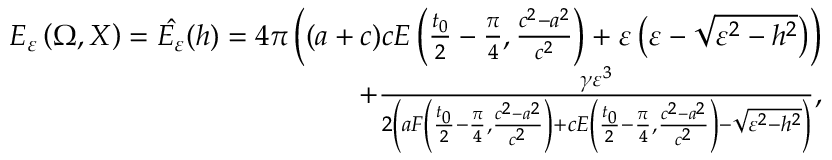Convert formula to latex. <formula><loc_0><loc_0><loc_500><loc_500>\begin{array} { r } { E _ { \varepsilon } \left ( \Omega , X \right ) = \hat { E _ { \varepsilon } } ( h ) = 4 \pi \left ( ( a + c ) c E \left ( \frac { t _ { 0 } } { 2 } - \frac { \pi } { 4 } , \frac { c ^ { 2 } - a ^ { 2 } } { c ^ { 2 } } \right ) + \varepsilon \left ( \varepsilon - \sqrt { \varepsilon ^ { 2 } - h ^ { 2 } } \right ) \right ) } \\ { + \frac { \gamma \varepsilon ^ { 3 } } { 2 \left ( a F \left ( \frac { t _ { 0 } } { 2 } - \frac { \pi } { 4 } , \frac { c ^ { 2 } - a ^ { 2 } } { c ^ { 2 } } \right ) + c E \left ( \frac { t _ { 0 } } { 2 } - \frac { \pi } { 4 } , \frac { c ^ { 2 } - a ^ { 2 } } { c ^ { 2 } } \right ) - \sqrt { \varepsilon ^ { 2 } - h ^ { 2 } } \right ) } , } \end{array}</formula> 